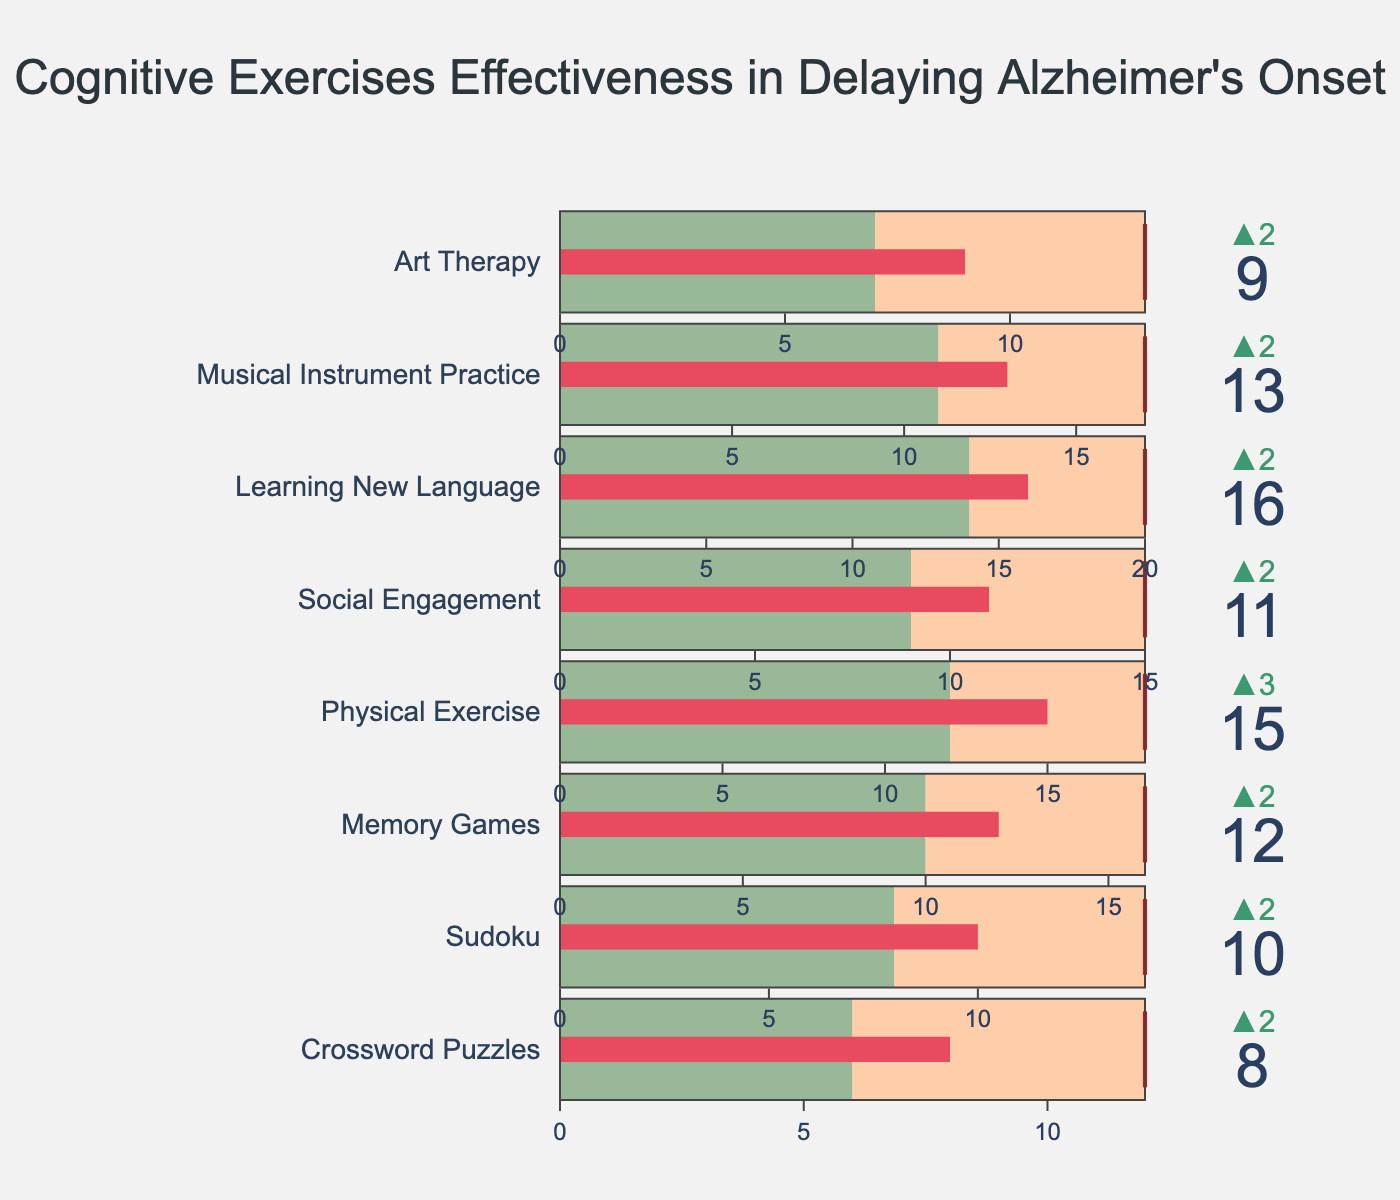What's the title of the chart? The title of the chart is clearly displayed at the top of the figure.
Answer: Cognitive Exercises Effectiveness in Delaying Alzheimer's Onset How many exercise types are displayed in the chart? There are individual bullet charts for each exercise type shown in a vertical sequence. By counting these, we can determine the number of exercise types represented.
Answer: 8 Which exercise type achieved an actual delay closest to its target delay? To find this, we compare the Actual Delay and Target Delay for each exercise type and find the minimum difference.
Answer: Physical Exercise What is the expected delay for Learning New Language? The expected delay is represented as a portion of the chart, marked typically in the first section of each bullet. By locating the Learning New Language row, we can read this value.
Answer: 14 months Which exercise type has the largest difference between expected delay and actual delay? Subtract the Expected Delay from the Actual Delay for each exercise type to find which has the largest difference.
Answer: Physical Exercise What's the total of the actual delays for all the exercise types? Summing up the Actual Delay values for all the exercise types listed. Calculation: 8 + 10 + 12 + 15 + 11 + 16 + 13 + 9 = 94
Answer: 94 months Which exercise types exceed their expected delay by more than 2 months? Identify the exercise types where (Actual Delay - Expected Delay) is greater than 2. By inspection, these types are listed.
Answer: Crossword Puzzles, Sudoku, Memory Games, Physical Exercise, Learning New Language, Musical Instrument Practice Compare the target delay and actual delay for Social Engagement. Which is higher? Directly compare the Actual Delay value with the Target Delay value for Social Engagement.
Answer: Target Delay Which exercise type has the smallest actual delay? Identify the exercise type with the smallest value in the Actual Delay column.
Answer: Crossword Puzzles By how many months did Art Therapy fall short of its target delay? Subtract the Actual Delay of Art Therapy from its Target Delay. Calculation: 13 - 9 = 4
Answer: 4 months 